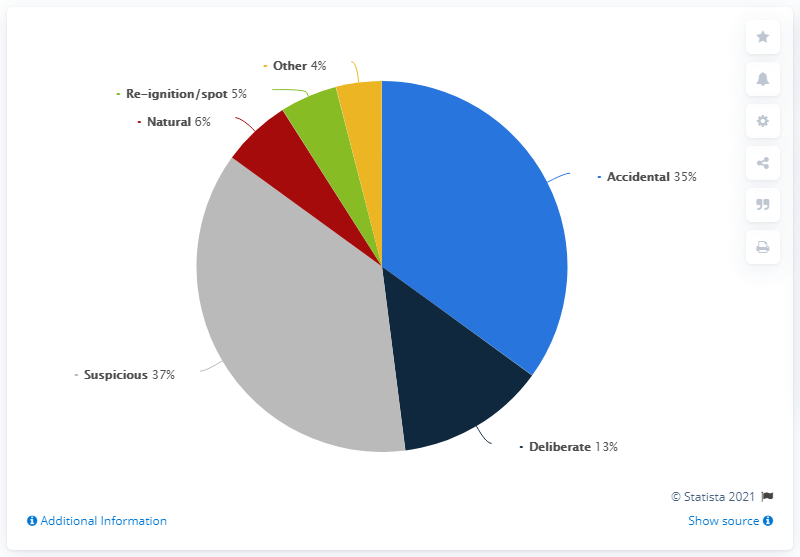Outline some significant characteristics in this image. The ratio of other to natural is approximately 0.666666667... Natural has a significant amount of shares. 